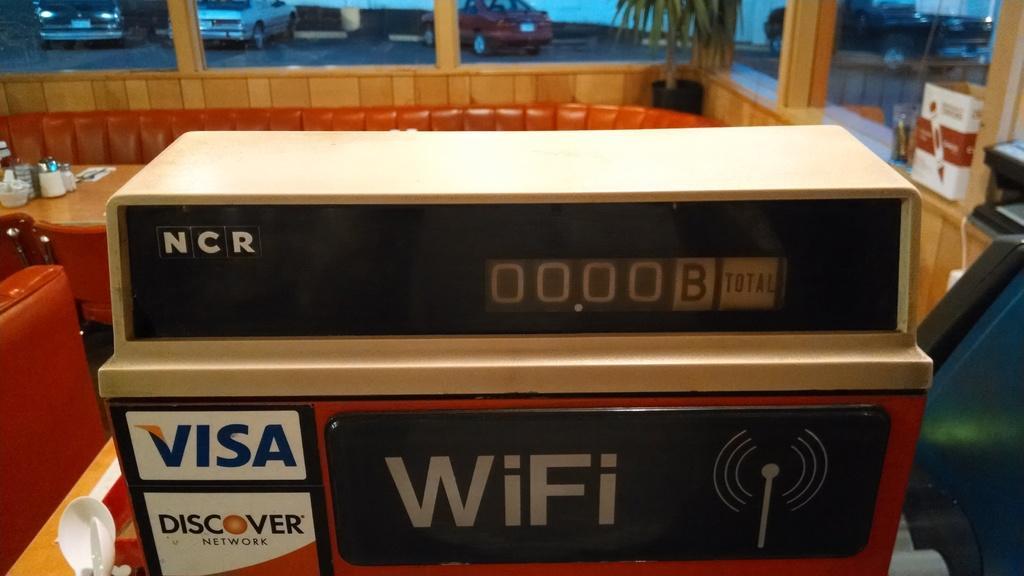Can you describe this image briefly? In this image we can see a device with some text, some spoons and a tray placed on the surface. On the left side of the image we can see some bowls, bottles and some objects placed on a table, we can also see some chairs. On the right side of the image we can see a device, cardboard box and a container placed on the surface. At the top of the image we can see some vehicles parked on the ground and some plants. 